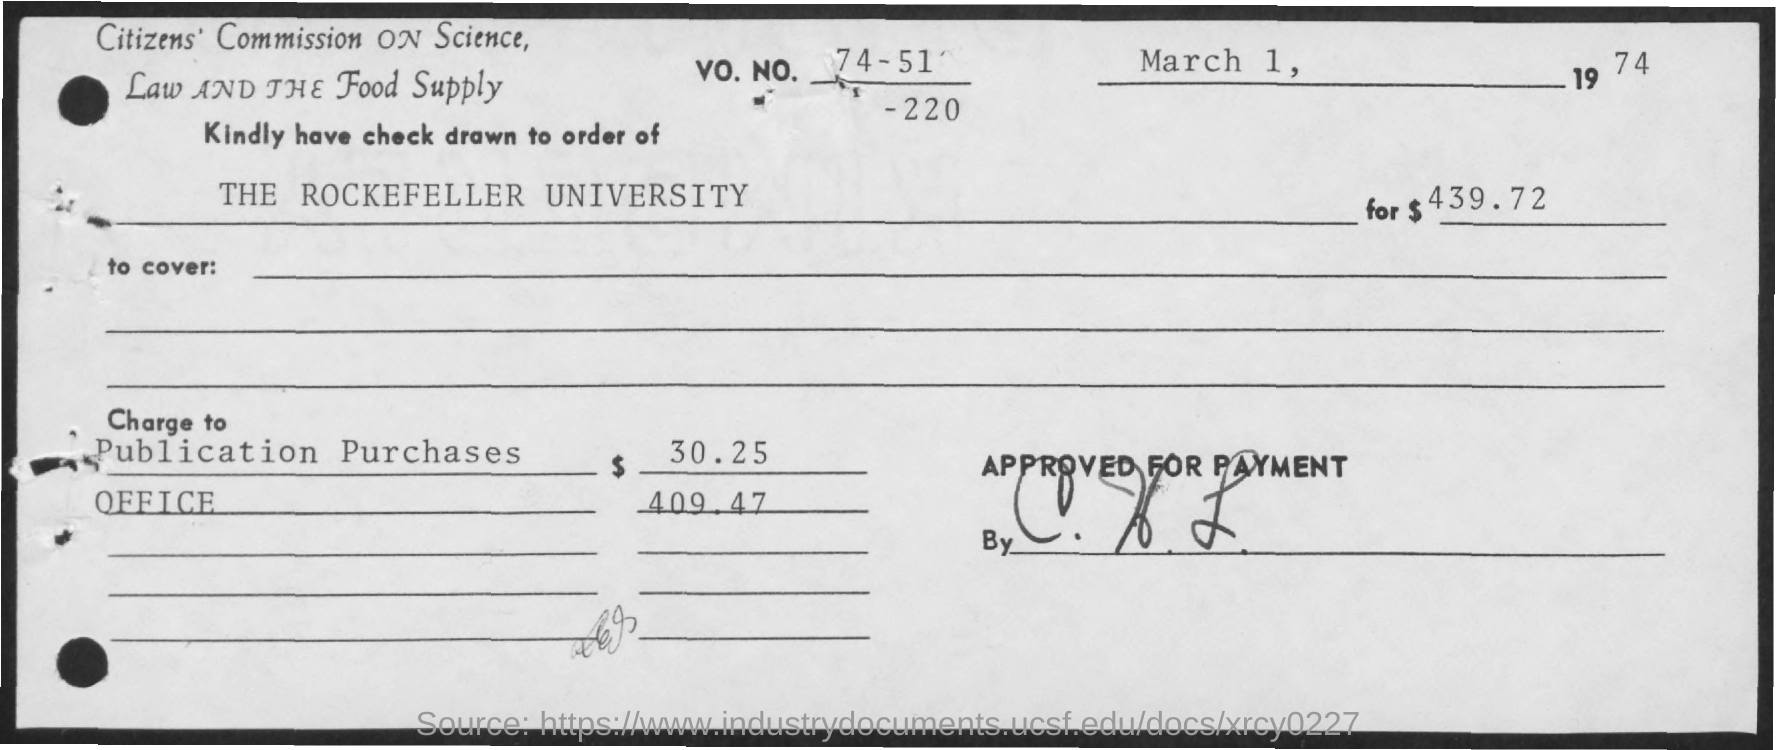Outline some significant characteristics in this image. The issued date of the check is March 1, 1974. What is the phone number mentioned in the check? It is 74-51-220... The check issued is for the amount of $439.72. 